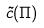<formula> <loc_0><loc_0><loc_500><loc_500>\tilde { c } ( \Pi )</formula> 